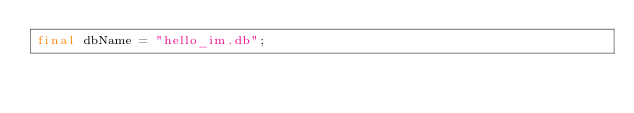Convert code to text. <code><loc_0><loc_0><loc_500><loc_500><_Dart_>final dbName = "hello_im.db";
</code> 